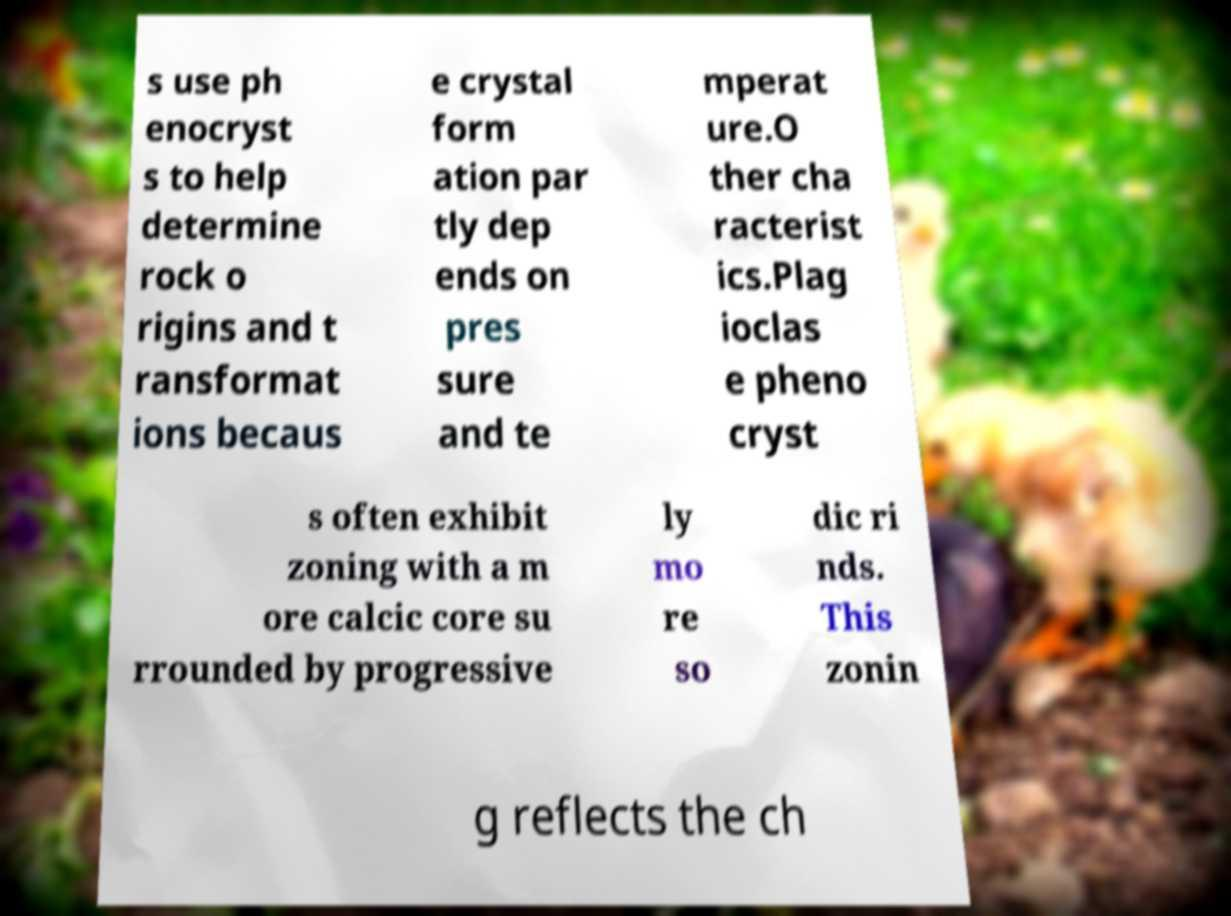There's text embedded in this image that I need extracted. Can you transcribe it verbatim? s use ph enocryst s to help determine rock o rigins and t ransformat ions becaus e crystal form ation par tly dep ends on pres sure and te mperat ure.O ther cha racterist ics.Plag ioclas e pheno cryst s often exhibit zoning with a m ore calcic core su rrounded by progressive ly mo re so dic ri nds. This zonin g reflects the ch 